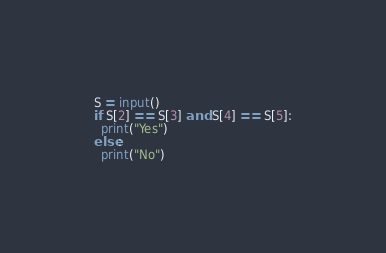Convert code to text. <code><loc_0><loc_0><loc_500><loc_500><_Python_>S = input()
if S[2] == S[3] and S[4] == S[5]:
  print("Yes")
else:
  print("No")</code> 